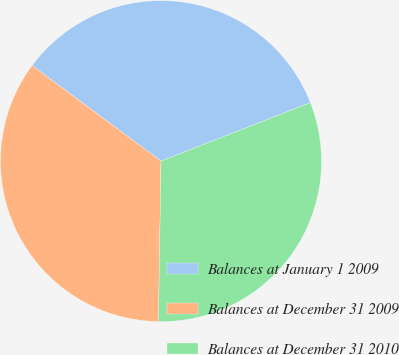<chart> <loc_0><loc_0><loc_500><loc_500><pie_chart><fcel>Balances at January 1 2009<fcel>Balances at December 31 2009<fcel>Balances at December 31 2010<nl><fcel>33.91%<fcel>34.9%<fcel>31.19%<nl></chart> 